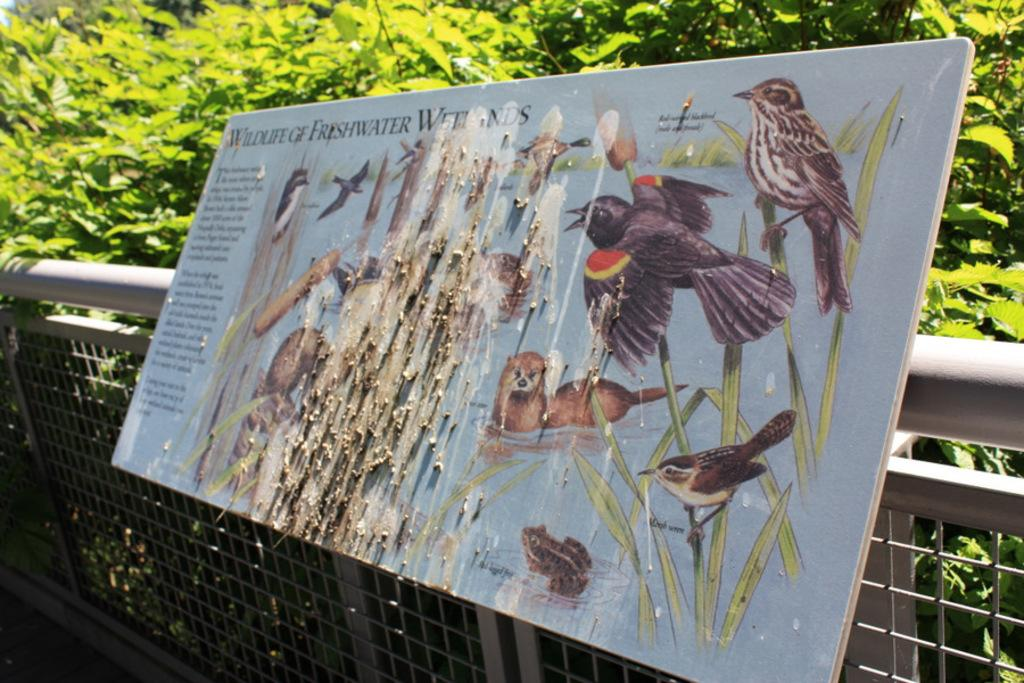What type of natural elements can be seen in the image? There are trees in the image. What type of structure is present in the image? There is fencing in the image. Is there anything attached to the fencing? Yes, a board is attached to the fencing. What level of difficulty does the beginner face when trying to slip through the cable in the image? There is no cable present in the image, so it is not possible to answer that question. 